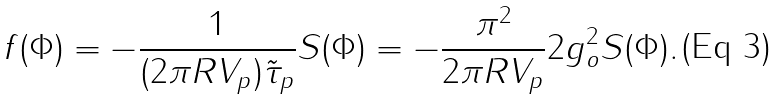Convert formula to latex. <formula><loc_0><loc_0><loc_500><loc_500>f ( \Phi ) = - \frac { 1 } { ( 2 \pi R V _ { p } ) \tilde { \tau } _ { p } } S ( \Phi ) = - \frac { \pi ^ { 2 } } { 2 \pi R V _ { p } } 2 g _ { o } ^ { 2 } S ( \Phi ) .</formula> 